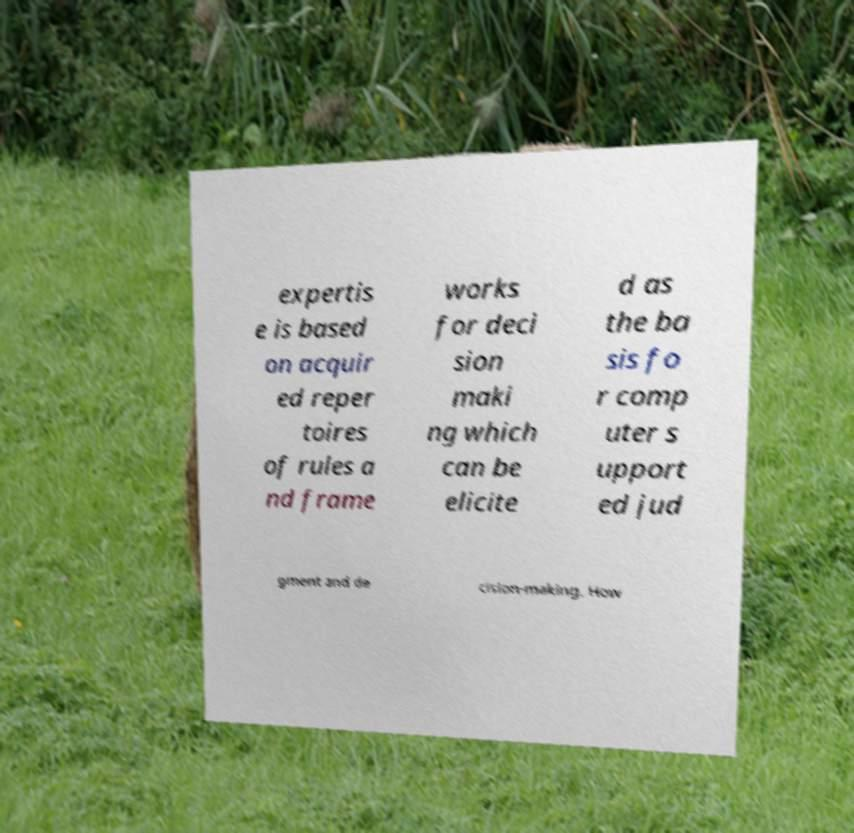Can you accurately transcribe the text from the provided image for me? expertis e is based on acquir ed reper toires of rules a nd frame works for deci sion maki ng which can be elicite d as the ba sis fo r comp uter s upport ed jud gment and de cision-making. How 